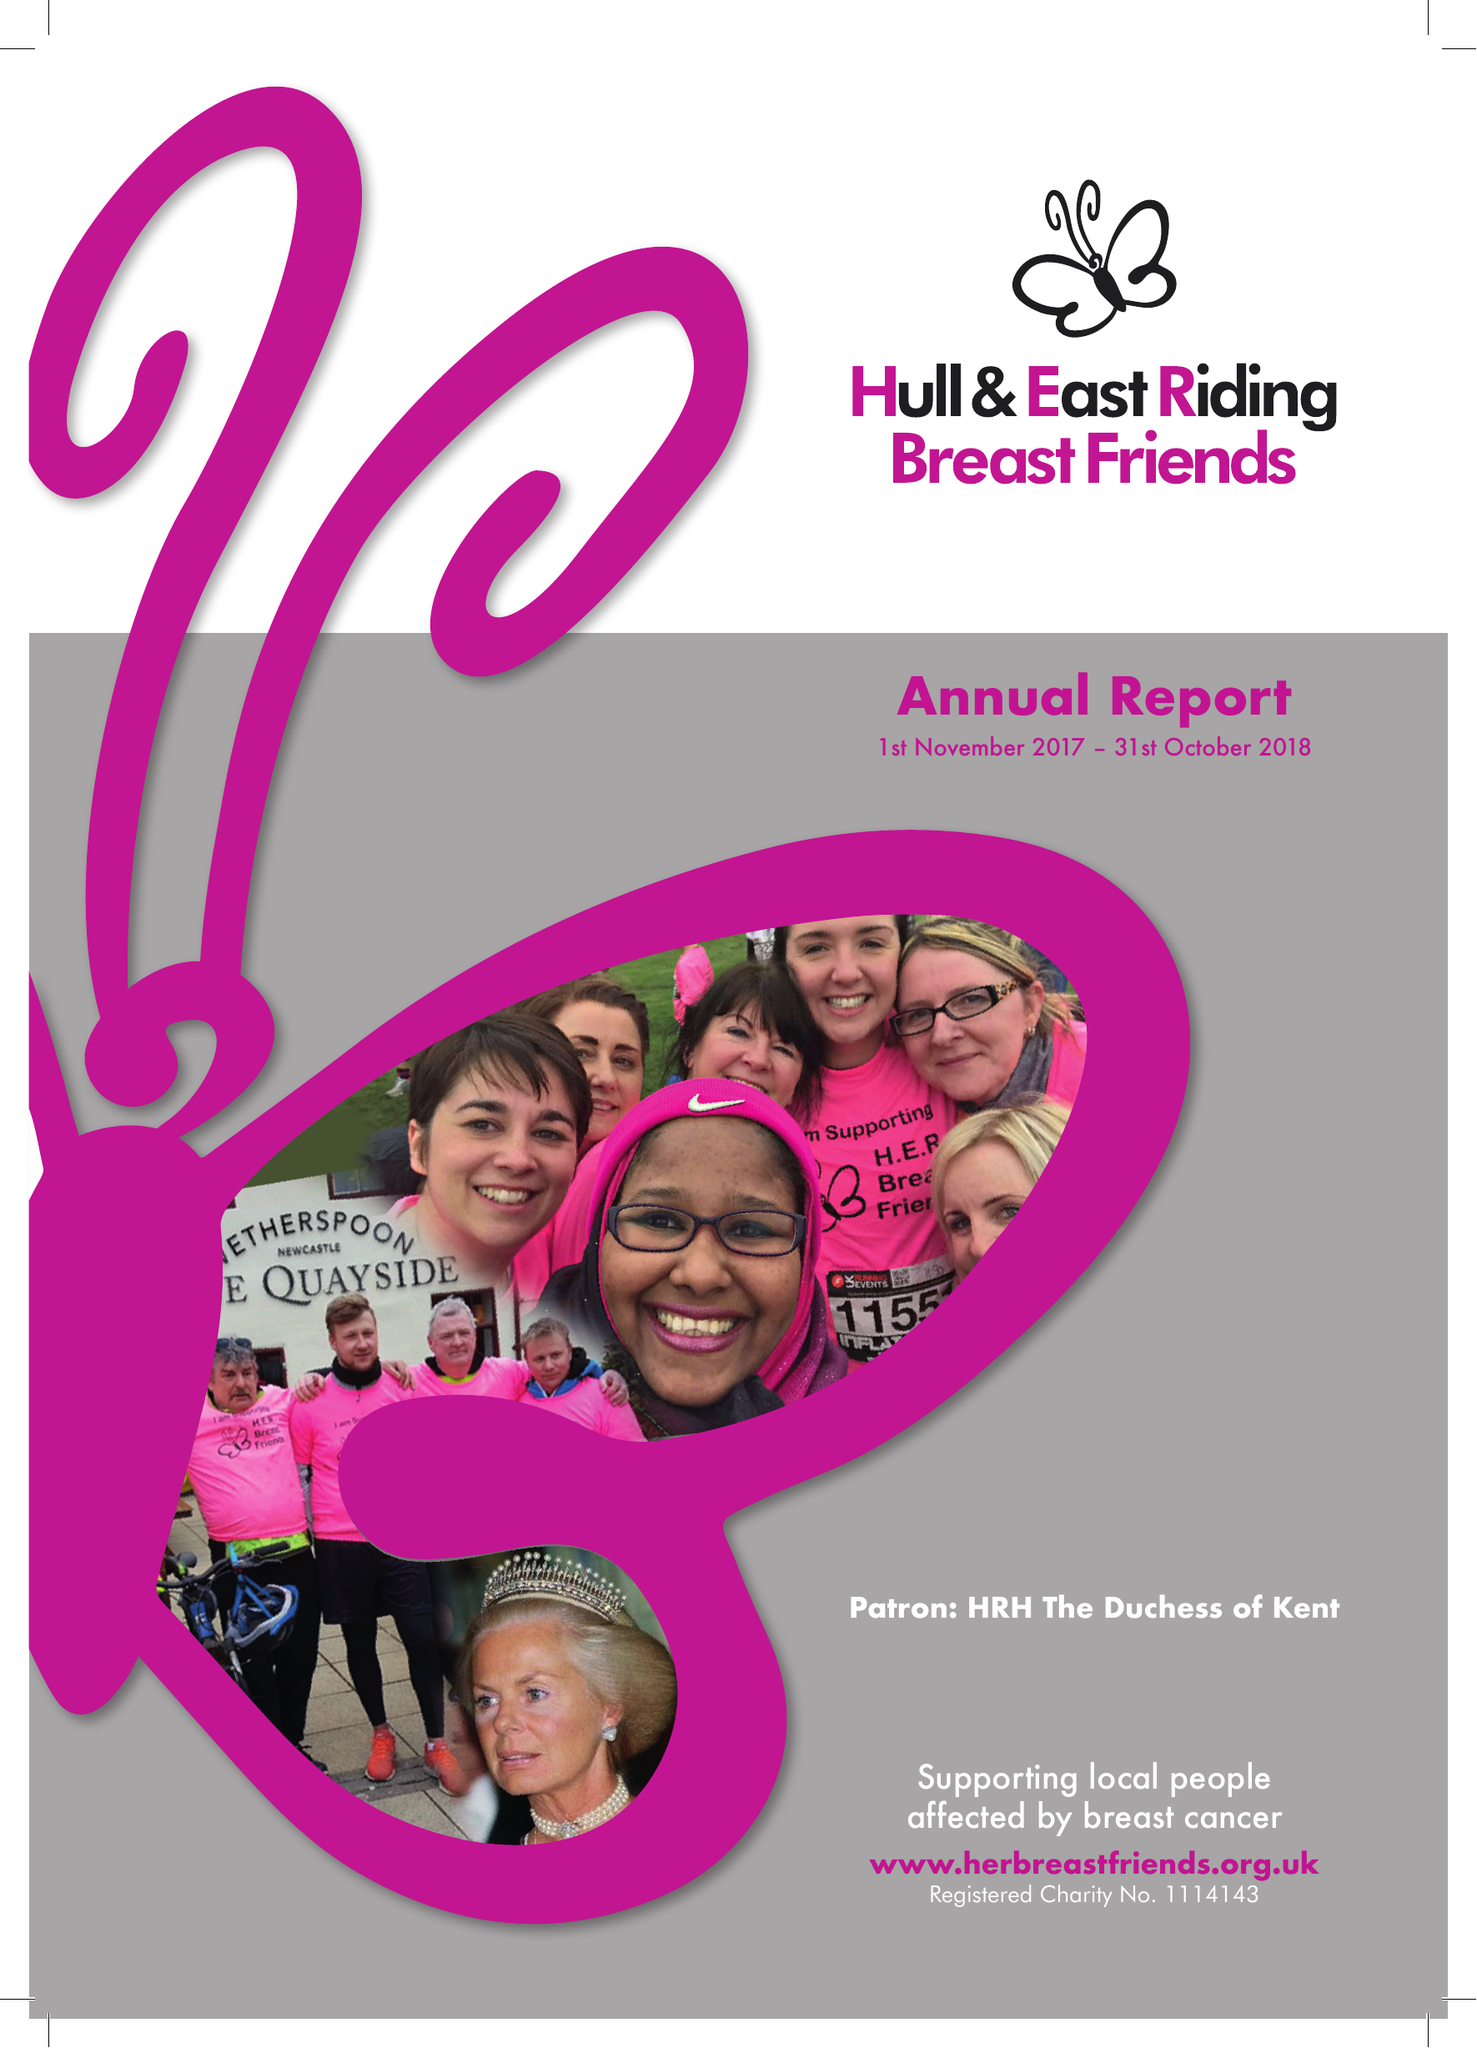What is the value for the address__street_line?
Answer the question using a single word or phrase. WALKER STREET 